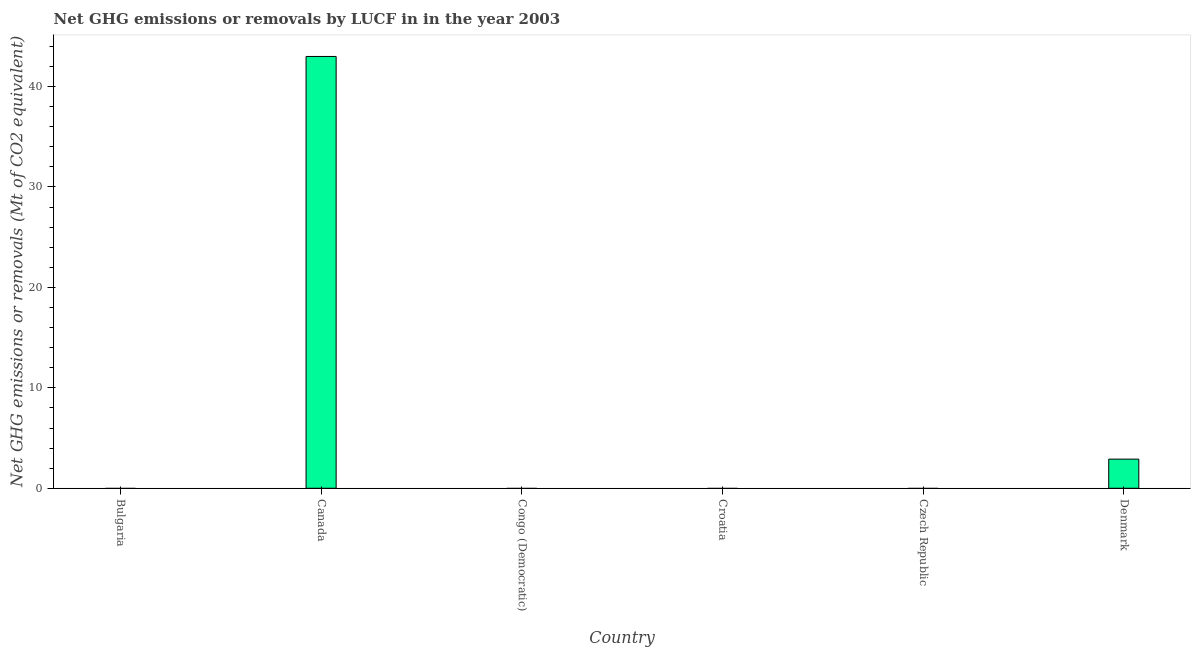What is the title of the graph?
Offer a very short reply. Net GHG emissions or removals by LUCF in in the year 2003. What is the label or title of the X-axis?
Your answer should be very brief. Country. What is the label or title of the Y-axis?
Provide a short and direct response. Net GHG emissions or removals (Mt of CO2 equivalent). Across all countries, what is the maximum ghg net emissions or removals?
Ensure brevity in your answer.  42.99. Across all countries, what is the minimum ghg net emissions or removals?
Offer a terse response. 0. What is the sum of the ghg net emissions or removals?
Ensure brevity in your answer.  45.89. What is the difference between the ghg net emissions or removals in Canada and Denmark?
Offer a terse response. 40.09. What is the average ghg net emissions or removals per country?
Your response must be concise. 7.65. What is the median ghg net emissions or removals?
Make the answer very short. 0. Is the difference between the ghg net emissions or removals in Canada and Denmark greater than the difference between any two countries?
Make the answer very short. No. What is the difference between the highest and the lowest ghg net emissions or removals?
Provide a short and direct response. 42.99. How many countries are there in the graph?
Offer a terse response. 6. What is the difference between two consecutive major ticks on the Y-axis?
Offer a very short reply. 10. What is the Net GHG emissions or removals (Mt of CO2 equivalent) of Bulgaria?
Your response must be concise. 0. What is the Net GHG emissions or removals (Mt of CO2 equivalent) of Canada?
Offer a very short reply. 42.99. What is the Net GHG emissions or removals (Mt of CO2 equivalent) in Congo (Democratic)?
Your response must be concise. 0. What is the Net GHG emissions or removals (Mt of CO2 equivalent) of Croatia?
Your answer should be compact. 0. What is the Net GHG emissions or removals (Mt of CO2 equivalent) of Denmark?
Offer a very short reply. 2.9. What is the difference between the Net GHG emissions or removals (Mt of CO2 equivalent) in Canada and Denmark?
Offer a very short reply. 40.09. What is the ratio of the Net GHG emissions or removals (Mt of CO2 equivalent) in Canada to that in Denmark?
Provide a short and direct response. 14.82. 